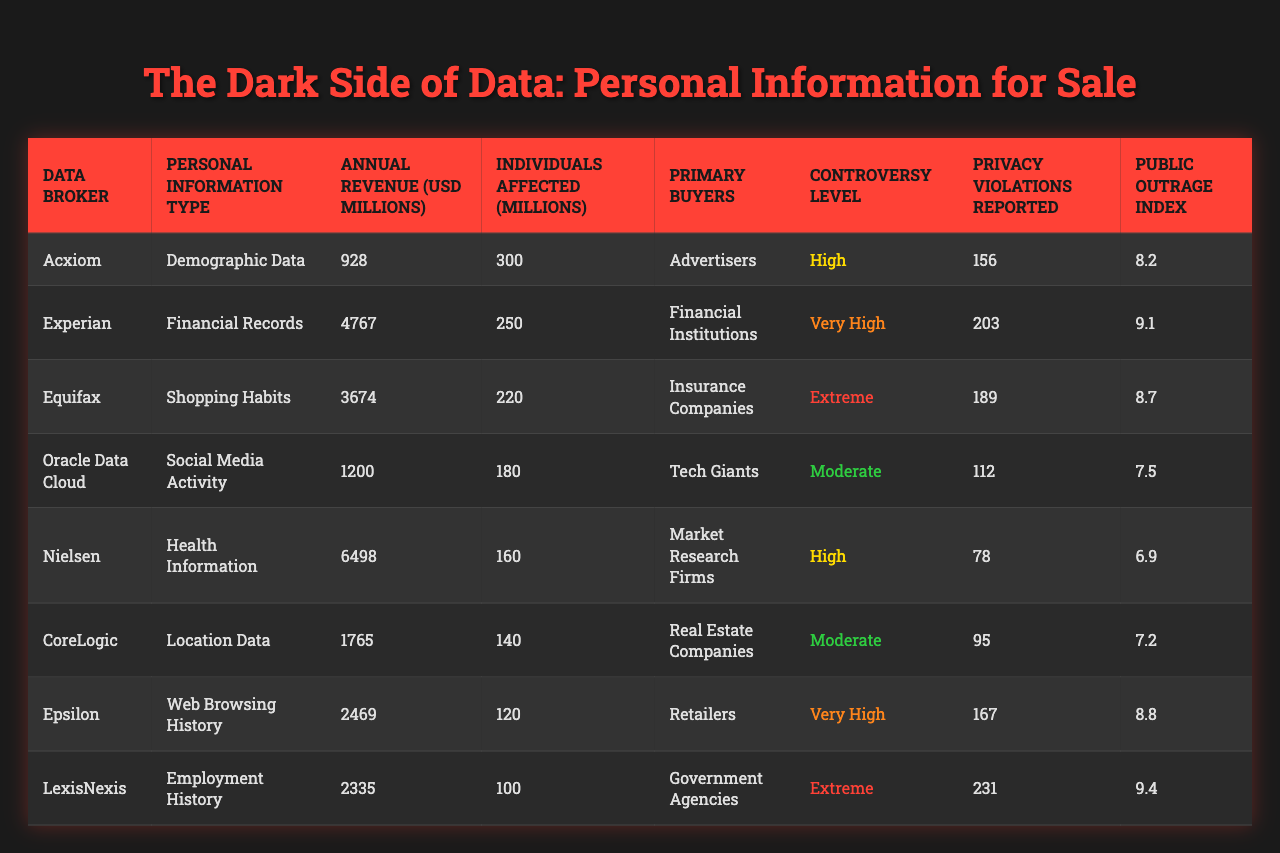What is the annual revenue of Acxiom? The table shows that the annual revenue for Acxiom is listed as 928 million USD.
Answer: 928 million USD How many individuals are affected by Experian's data practices? According to the table, Experian affects 250 million individuals.
Answer: 250 million individuals Which company has the highest annual revenue? By reviewing the annual revenue figures, Nielsen has the highest total at 6498 million USD.
Answer: Nielsen What is the primary buyer for Oracle Data Cloud? The table states that the primary buyer for Oracle Data Cloud is Tech Giants.
Answer: Tech Giants How many privacy violations have been reported for LexisNexis? The table indicates that LexisNexis has reported 231 privacy violations.
Answer: 231 violations What is the controversy level associated with Equifax? The table states that Equifax is marked as having an extreme level of controversy.
Answer: Extreme Which data broker affects the fewest individuals? Looking at the 'Individuals Affected' column, LexisNexis affects the fewest individuals at 100 million.
Answer: LexisNexis What is the average annual revenue across all data brokers? To calculate the average, sum the annual revenues (928 + 4767 + 3674 + 1200 + 6498 + 1765 + 2469 + 2335 = 18836) and divide by 8, yielding 2354.5 million USD.
Answer: 2354.5 million USD Which data broker has the lowest Public Outrage Index? The table shows that Nielsen has the lowest Public Outrage Index at 6.9.
Answer: 6.9 Are there any data brokers with a controversy level rated as moderate? The table confirms there are two data brokers (CoreLogic and Oracle Data Cloud) with a controversy level of moderate.
Answer: Yes 